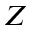Convert formula to latex. <formula><loc_0><loc_0><loc_500><loc_500>Z</formula> 